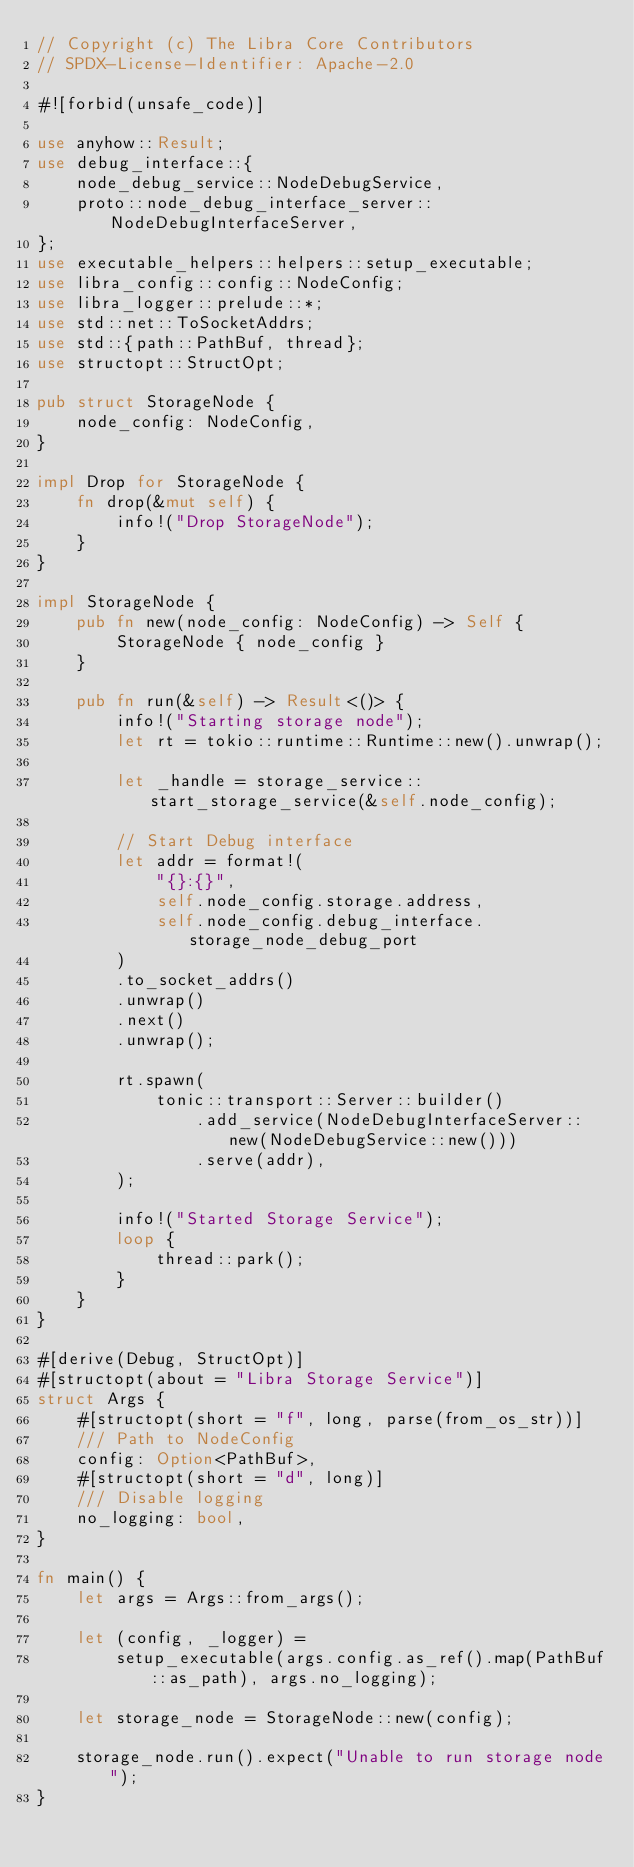<code> <loc_0><loc_0><loc_500><loc_500><_Rust_>// Copyright (c) The Libra Core Contributors
// SPDX-License-Identifier: Apache-2.0

#![forbid(unsafe_code)]

use anyhow::Result;
use debug_interface::{
    node_debug_service::NodeDebugService,
    proto::node_debug_interface_server::NodeDebugInterfaceServer,
};
use executable_helpers::helpers::setup_executable;
use libra_config::config::NodeConfig;
use libra_logger::prelude::*;
use std::net::ToSocketAddrs;
use std::{path::PathBuf, thread};
use structopt::StructOpt;

pub struct StorageNode {
    node_config: NodeConfig,
}

impl Drop for StorageNode {
    fn drop(&mut self) {
        info!("Drop StorageNode");
    }
}

impl StorageNode {
    pub fn new(node_config: NodeConfig) -> Self {
        StorageNode { node_config }
    }

    pub fn run(&self) -> Result<()> {
        info!("Starting storage node");
        let rt = tokio::runtime::Runtime::new().unwrap();

        let _handle = storage_service::start_storage_service(&self.node_config);

        // Start Debug interface
        let addr = format!(
            "{}:{}",
            self.node_config.storage.address,
            self.node_config.debug_interface.storage_node_debug_port
        )
        .to_socket_addrs()
        .unwrap()
        .next()
        .unwrap();

        rt.spawn(
            tonic::transport::Server::builder()
                .add_service(NodeDebugInterfaceServer::new(NodeDebugService::new()))
                .serve(addr),
        );

        info!("Started Storage Service");
        loop {
            thread::park();
        }
    }
}

#[derive(Debug, StructOpt)]
#[structopt(about = "Libra Storage Service")]
struct Args {
    #[structopt(short = "f", long, parse(from_os_str))]
    /// Path to NodeConfig
    config: Option<PathBuf>,
    #[structopt(short = "d", long)]
    /// Disable logging
    no_logging: bool,
}

fn main() {
    let args = Args::from_args();

    let (config, _logger) =
        setup_executable(args.config.as_ref().map(PathBuf::as_path), args.no_logging);

    let storage_node = StorageNode::new(config);

    storage_node.run().expect("Unable to run storage node");
}
</code> 